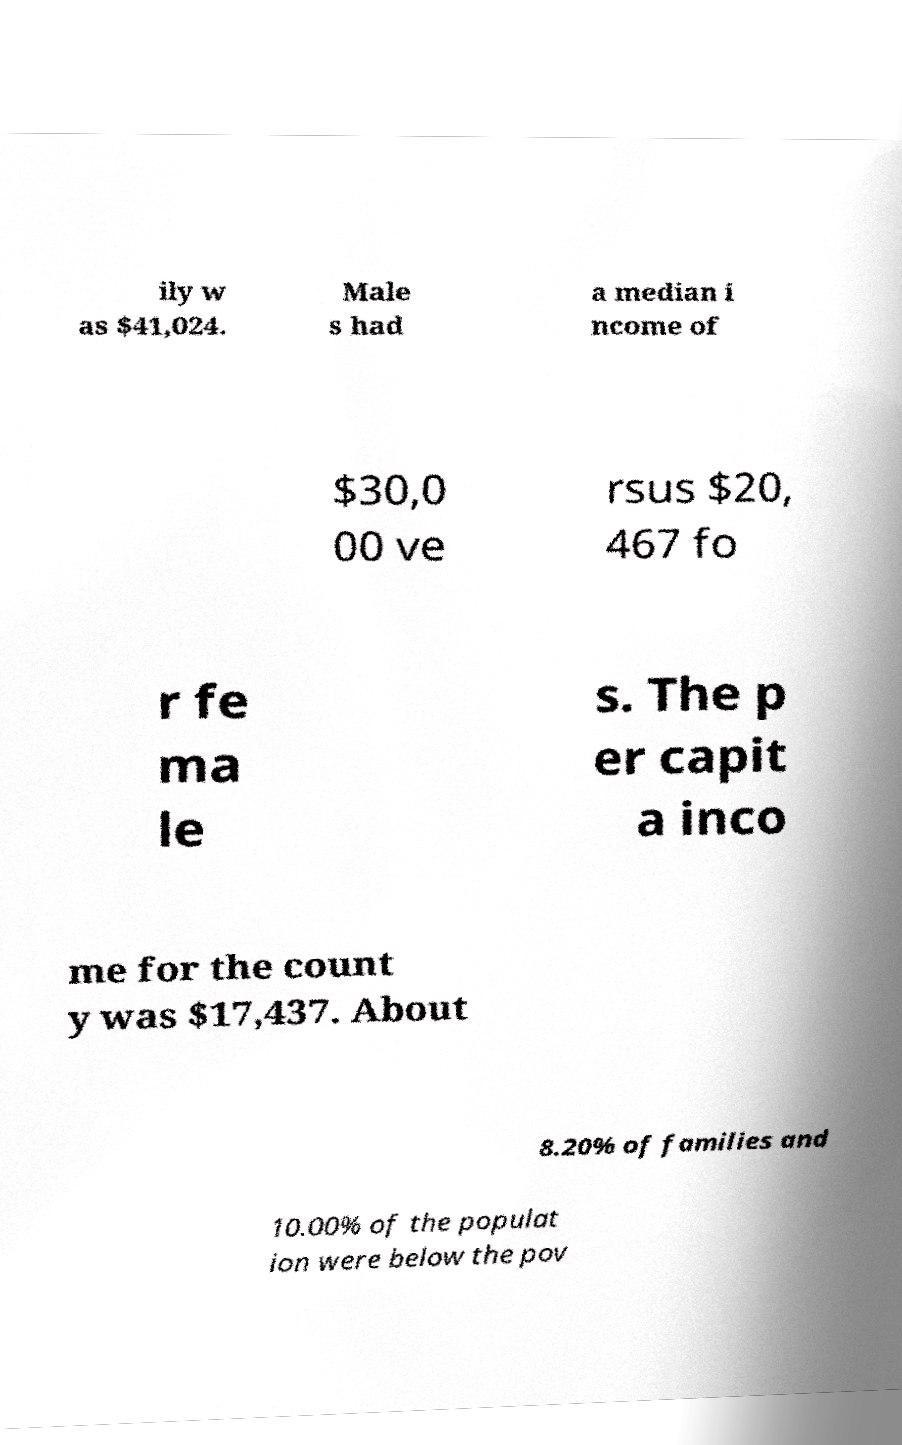Please read and relay the text visible in this image. What does it say? ily w as $41,024. Male s had a median i ncome of $30,0 00 ve rsus $20, 467 fo r fe ma le s. The p er capit a inco me for the count y was $17,437. About 8.20% of families and 10.00% of the populat ion were below the pov 